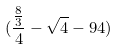Convert formula to latex. <formula><loc_0><loc_0><loc_500><loc_500>( \frac { \frac { 8 } { 3 } } { 4 } - \sqrt { 4 } - 9 4 )</formula> 